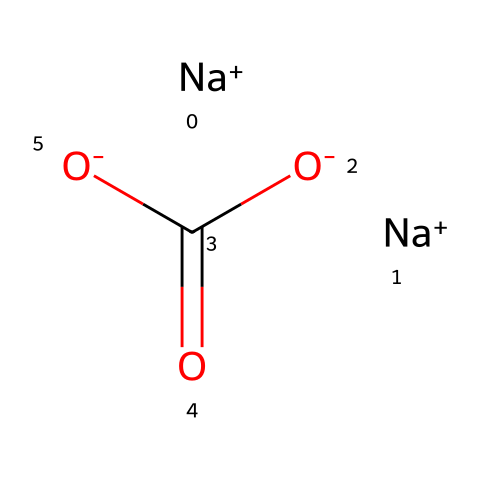What is the molecular formula of sodium carbonate? The SMILES notation shows the arrangement of sodium (Na) and carbonate ions (CO3). From the representation, there are 2 sodium ions and one carbonate group, which corresponds to the formula Na2CO3.
Answer: Na2CO3 How many sodium atoms are present in this structure? By examining the SMILES, we see 2 instances of sodium indicated by [Na+], which shows there are 2 sodium atoms in total.
Answer: 2 What is the charge of the carbonate ion in this structure? The carbonate part, indicated as (O-)(C=O)(O-), has a total of two negative charges. Each negatively charged oxygen contributes to the charge of the carbonate ion, indicating that it is indeed a doubly negative ion, charged -2 overall.
Answer: -2 What type of ion is sodium in this chemical? The notation [Na+] indicates sodium is a cation because it has a positive charge. Therefore, sodium in this structure is classified as a cation.
Answer: cation Why is sodium carbonate considered an alkaline builder in detergents? Sodium carbonate dissociates in water to produce hydroxide ions (OH-), making the solution basic (alkaline). This increase in pH enhances the efficiency of surfactants in detergents, making it useful as a builder.
Answer: alkaline What role do the carbonate groups play in laundry detergents? The carbonate groups help to soften water by binding with calcium and magnesium ions, thereby preventing these ions from interfering with the cleaning action of the detergent. This function is critical for improving detergent performance.
Answer: soften water 